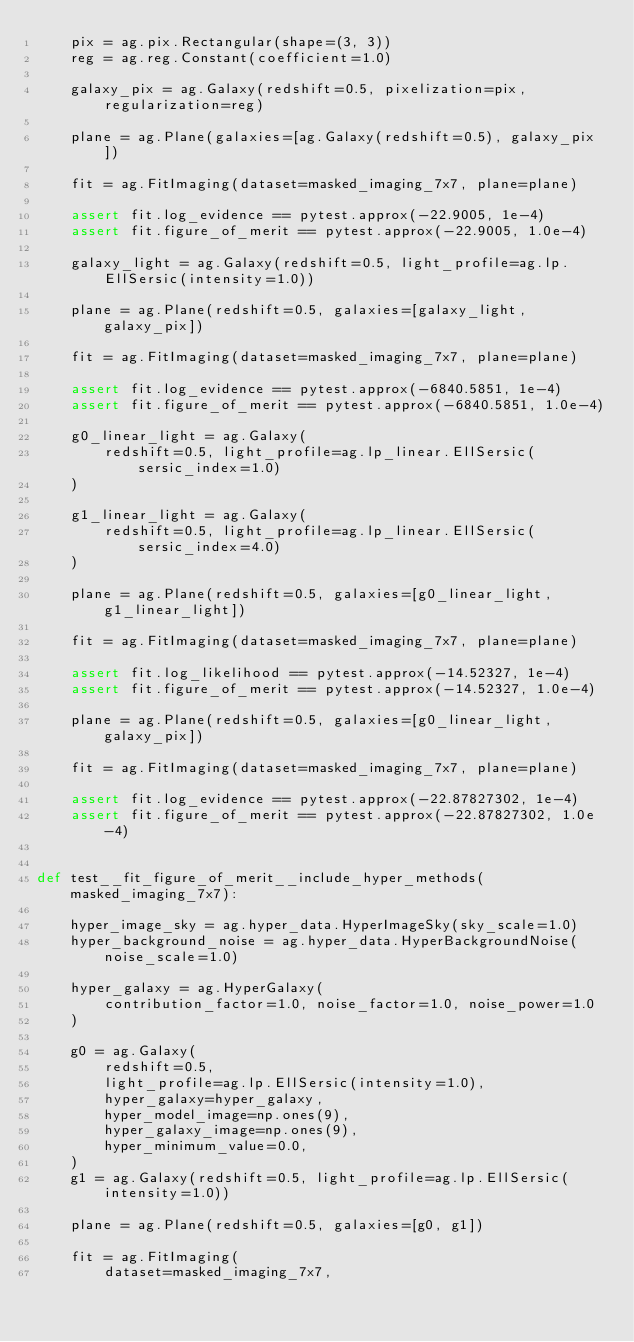<code> <loc_0><loc_0><loc_500><loc_500><_Python_>    pix = ag.pix.Rectangular(shape=(3, 3))
    reg = ag.reg.Constant(coefficient=1.0)

    galaxy_pix = ag.Galaxy(redshift=0.5, pixelization=pix, regularization=reg)

    plane = ag.Plane(galaxies=[ag.Galaxy(redshift=0.5), galaxy_pix])

    fit = ag.FitImaging(dataset=masked_imaging_7x7, plane=plane)

    assert fit.log_evidence == pytest.approx(-22.9005, 1e-4)
    assert fit.figure_of_merit == pytest.approx(-22.9005, 1.0e-4)

    galaxy_light = ag.Galaxy(redshift=0.5, light_profile=ag.lp.EllSersic(intensity=1.0))

    plane = ag.Plane(redshift=0.5, galaxies=[galaxy_light, galaxy_pix])

    fit = ag.FitImaging(dataset=masked_imaging_7x7, plane=plane)

    assert fit.log_evidence == pytest.approx(-6840.5851, 1e-4)
    assert fit.figure_of_merit == pytest.approx(-6840.5851, 1.0e-4)

    g0_linear_light = ag.Galaxy(
        redshift=0.5, light_profile=ag.lp_linear.EllSersic(sersic_index=1.0)
    )

    g1_linear_light = ag.Galaxy(
        redshift=0.5, light_profile=ag.lp_linear.EllSersic(sersic_index=4.0)
    )

    plane = ag.Plane(redshift=0.5, galaxies=[g0_linear_light, g1_linear_light])

    fit = ag.FitImaging(dataset=masked_imaging_7x7, plane=plane)

    assert fit.log_likelihood == pytest.approx(-14.52327, 1e-4)
    assert fit.figure_of_merit == pytest.approx(-14.52327, 1.0e-4)

    plane = ag.Plane(redshift=0.5, galaxies=[g0_linear_light, galaxy_pix])

    fit = ag.FitImaging(dataset=masked_imaging_7x7, plane=plane)

    assert fit.log_evidence == pytest.approx(-22.87827302, 1e-4)
    assert fit.figure_of_merit == pytest.approx(-22.87827302, 1.0e-4)


def test__fit_figure_of_merit__include_hyper_methods(masked_imaging_7x7):

    hyper_image_sky = ag.hyper_data.HyperImageSky(sky_scale=1.0)
    hyper_background_noise = ag.hyper_data.HyperBackgroundNoise(noise_scale=1.0)

    hyper_galaxy = ag.HyperGalaxy(
        contribution_factor=1.0, noise_factor=1.0, noise_power=1.0
    )

    g0 = ag.Galaxy(
        redshift=0.5,
        light_profile=ag.lp.EllSersic(intensity=1.0),
        hyper_galaxy=hyper_galaxy,
        hyper_model_image=np.ones(9),
        hyper_galaxy_image=np.ones(9),
        hyper_minimum_value=0.0,
    )
    g1 = ag.Galaxy(redshift=0.5, light_profile=ag.lp.EllSersic(intensity=1.0))

    plane = ag.Plane(redshift=0.5, galaxies=[g0, g1])

    fit = ag.FitImaging(
        dataset=masked_imaging_7x7,</code> 